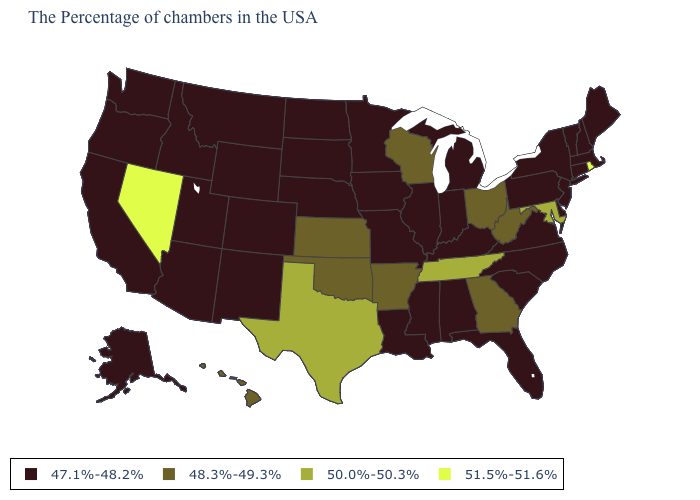What is the value of Colorado?
Be succinct. 47.1%-48.2%. What is the lowest value in the USA?
Quick response, please. 47.1%-48.2%. What is the value of New York?
Short answer required. 47.1%-48.2%. Is the legend a continuous bar?
Be succinct. No. Which states hav the highest value in the South?
Give a very brief answer. Maryland, Tennessee, Texas. Does Rhode Island have the lowest value in the Northeast?
Concise answer only. No. How many symbols are there in the legend?
Write a very short answer. 4. Which states hav the highest value in the MidWest?
Quick response, please. Ohio, Wisconsin, Kansas. What is the lowest value in the South?
Quick response, please. 47.1%-48.2%. What is the value of Kansas?
Short answer required. 48.3%-49.3%. Which states have the lowest value in the USA?
Answer briefly. Maine, Massachusetts, New Hampshire, Vermont, Connecticut, New York, New Jersey, Delaware, Pennsylvania, Virginia, North Carolina, South Carolina, Florida, Michigan, Kentucky, Indiana, Alabama, Illinois, Mississippi, Louisiana, Missouri, Minnesota, Iowa, Nebraska, South Dakota, North Dakota, Wyoming, Colorado, New Mexico, Utah, Montana, Arizona, Idaho, California, Washington, Oregon, Alaska. Does Virginia have a lower value than Indiana?
Quick response, please. No. Does New Mexico have the same value as Wyoming?
Write a very short answer. Yes. Name the states that have a value in the range 51.5%-51.6%?
Answer briefly. Rhode Island, Nevada. Name the states that have a value in the range 47.1%-48.2%?
Write a very short answer. Maine, Massachusetts, New Hampshire, Vermont, Connecticut, New York, New Jersey, Delaware, Pennsylvania, Virginia, North Carolina, South Carolina, Florida, Michigan, Kentucky, Indiana, Alabama, Illinois, Mississippi, Louisiana, Missouri, Minnesota, Iowa, Nebraska, South Dakota, North Dakota, Wyoming, Colorado, New Mexico, Utah, Montana, Arizona, Idaho, California, Washington, Oregon, Alaska. 